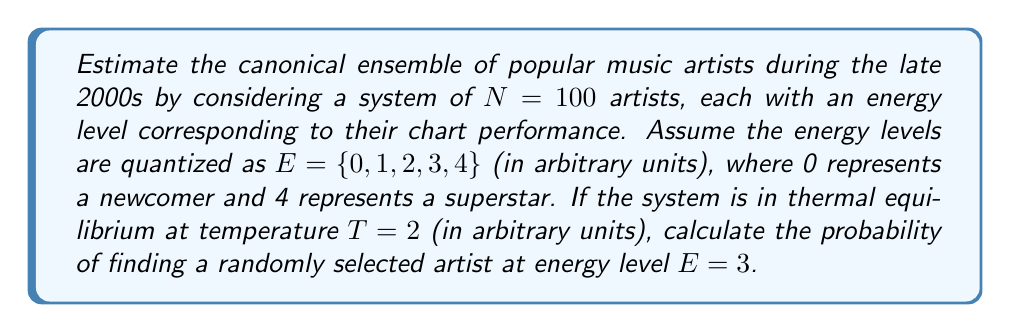Can you solve this math problem? To solve this problem, we'll use the canonical ensemble approach from statistical mechanics:

1. The probability of finding a system in a particular microstate is given by the Boltzmann distribution:

   $$P(E) = \frac{1}{Z} e^{-\beta E}$$

   where $\beta = \frac{1}{k_B T}$ and $Z$ is the partition function.

2. In this case, $k_B = 1$ (arbitrary units) and $T = 2$, so $\beta = \frac{1}{2}$.

3. Calculate the partition function $Z$:

   $$Z = \sum_{E=0}^{4} e^{-\beta E} = e^{0} + e^{-1/2} + e^{-1} + e^{-3/2} + e^{-2}$$

4. Evaluate $Z$ numerically:

   $$Z \approx 1 + 0.6065 + 0.3679 + 0.2231 + 0.1353 \approx 2.3328$$

5. Now calculate the probability for $E = 3$:

   $$P(E=3) = \frac{1}{Z} e^{-\beta E} = \frac{1}{2.3328} e^{-3/2} \approx 0.0956$$

6. Convert to a percentage:

   $$P(E=3) \approx 9.56\%$$
Answer: 9.56% 